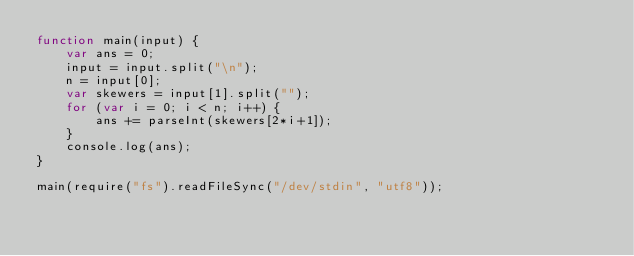<code> <loc_0><loc_0><loc_500><loc_500><_JavaScript_>function main(input) {
    var ans = 0;
    input = input.split("\n");
    n = input[0];
    var skewers = input[1].split("");   
    for (var i = 0; i < n; i++) {
        ans += parseInt(skewers[2*i+1]);
    }
    console.log(ans);
}

main(require("fs").readFileSync("/dev/stdin", "utf8"));</code> 